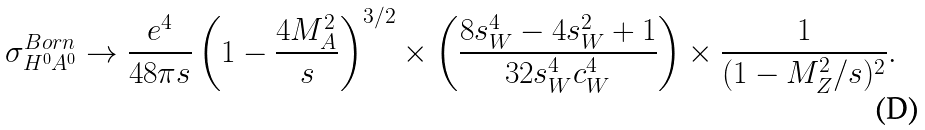<formula> <loc_0><loc_0><loc_500><loc_500>\sigma ^ { B o r n } _ { H ^ { 0 } A ^ { 0 } } \rightarrow \frac { e ^ { 4 } } { 4 8 \pi s } \left ( 1 - \frac { 4 M _ { A } ^ { 2 } } { s } \right ) ^ { 3 / 2 } \times \left ( \frac { 8 s ^ { 4 } _ { W } - 4 s ^ { 2 } _ { W } + 1 } { 3 2 s ^ { 4 } _ { W } c ^ { 4 } _ { W } } \right ) \times \frac { 1 } { ( 1 - M _ { Z } ^ { 2 } / s ) ^ { 2 } } .</formula> 